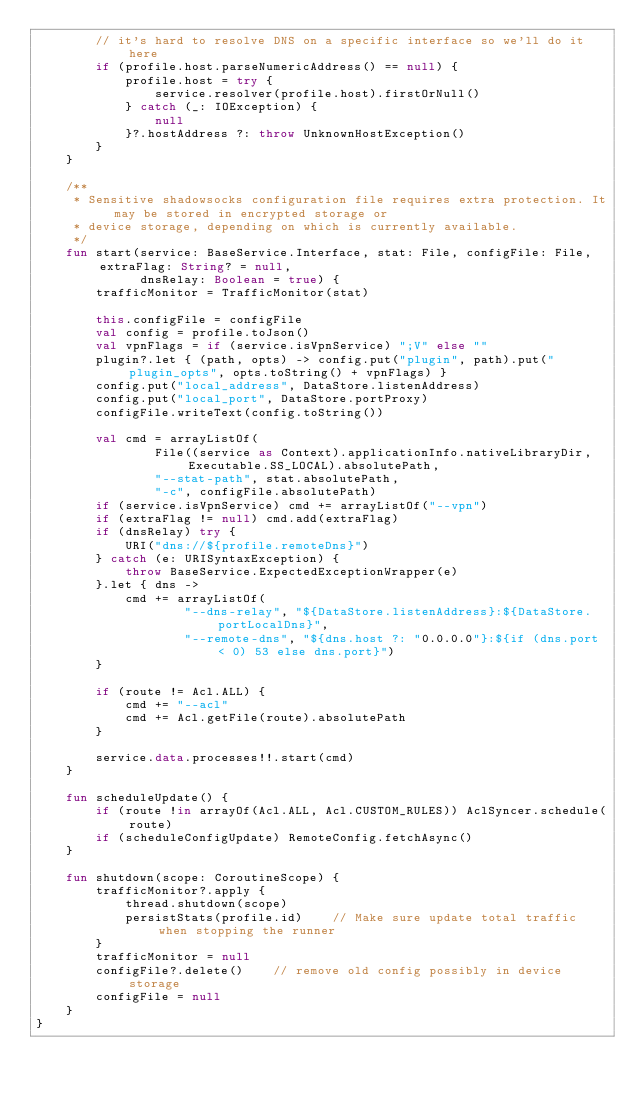<code> <loc_0><loc_0><loc_500><loc_500><_Kotlin_>        // it's hard to resolve DNS on a specific interface so we'll do it here
        if (profile.host.parseNumericAddress() == null) {
            profile.host = try {
                service.resolver(profile.host).firstOrNull()
            } catch (_: IOException) {
                null
            }?.hostAddress ?: throw UnknownHostException()
        }
    }

    /**
     * Sensitive shadowsocks configuration file requires extra protection. It may be stored in encrypted storage or
     * device storage, depending on which is currently available.
     */
    fun start(service: BaseService.Interface, stat: File, configFile: File, extraFlag: String? = null,
              dnsRelay: Boolean = true) {
        trafficMonitor = TrafficMonitor(stat)

        this.configFile = configFile
        val config = profile.toJson()
        val vpnFlags = if (service.isVpnService) ";V" else ""
        plugin?.let { (path, opts) -> config.put("plugin", path).put("plugin_opts", opts.toString() + vpnFlags) }
        config.put("local_address", DataStore.listenAddress)
        config.put("local_port", DataStore.portProxy)
        configFile.writeText(config.toString())

        val cmd = arrayListOf(
                File((service as Context).applicationInfo.nativeLibraryDir, Executable.SS_LOCAL).absolutePath,
                "--stat-path", stat.absolutePath,
                "-c", configFile.absolutePath)
        if (service.isVpnService) cmd += arrayListOf("--vpn")
        if (extraFlag != null) cmd.add(extraFlag)
        if (dnsRelay) try {
            URI("dns://${profile.remoteDns}")
        } catch (e: URISyntaxException) {
            throw BaseService.ExpectedExceptionWrapper(e)
        }.let { dns ->
            cmd += arrayListOf(
                    "--dns-relay", "${DataStore.listenAddress}:${DataStore.portLocalDns}",
                    "--remote-dns", "${dns.host ?: "0.0.0.0"}:${if (dns.port < 0) 53 else dns.port}")
        }

        if (route != Acl.ALL) {
            cmd += "--acl"
            cmd += Acl.getFile(route).absolutePath
        }

        service.data.processes!!.start(cmd)
    }

    fun scheduleUpdate() {
        if (route !in arrayOf(Acl.ALL, Acl.CUSTOM_RULES)) AclSyncer.schedule(route)
        if (scheduleConfigUpdate) RemoteConfig.fetchAsync()
    }

    fun shutdown(scope: CoroutineScope) {
        trafficMonitor?.apply {
            thread.shutdown(scope)
            persistStats(profile.id)    // Make sure update total traffic when stopping the runner
        }
        trafficMonitor = null
        configFile?.delete()    // remove old config possibly in device storage
        configFile = null
    }
}
</code> 